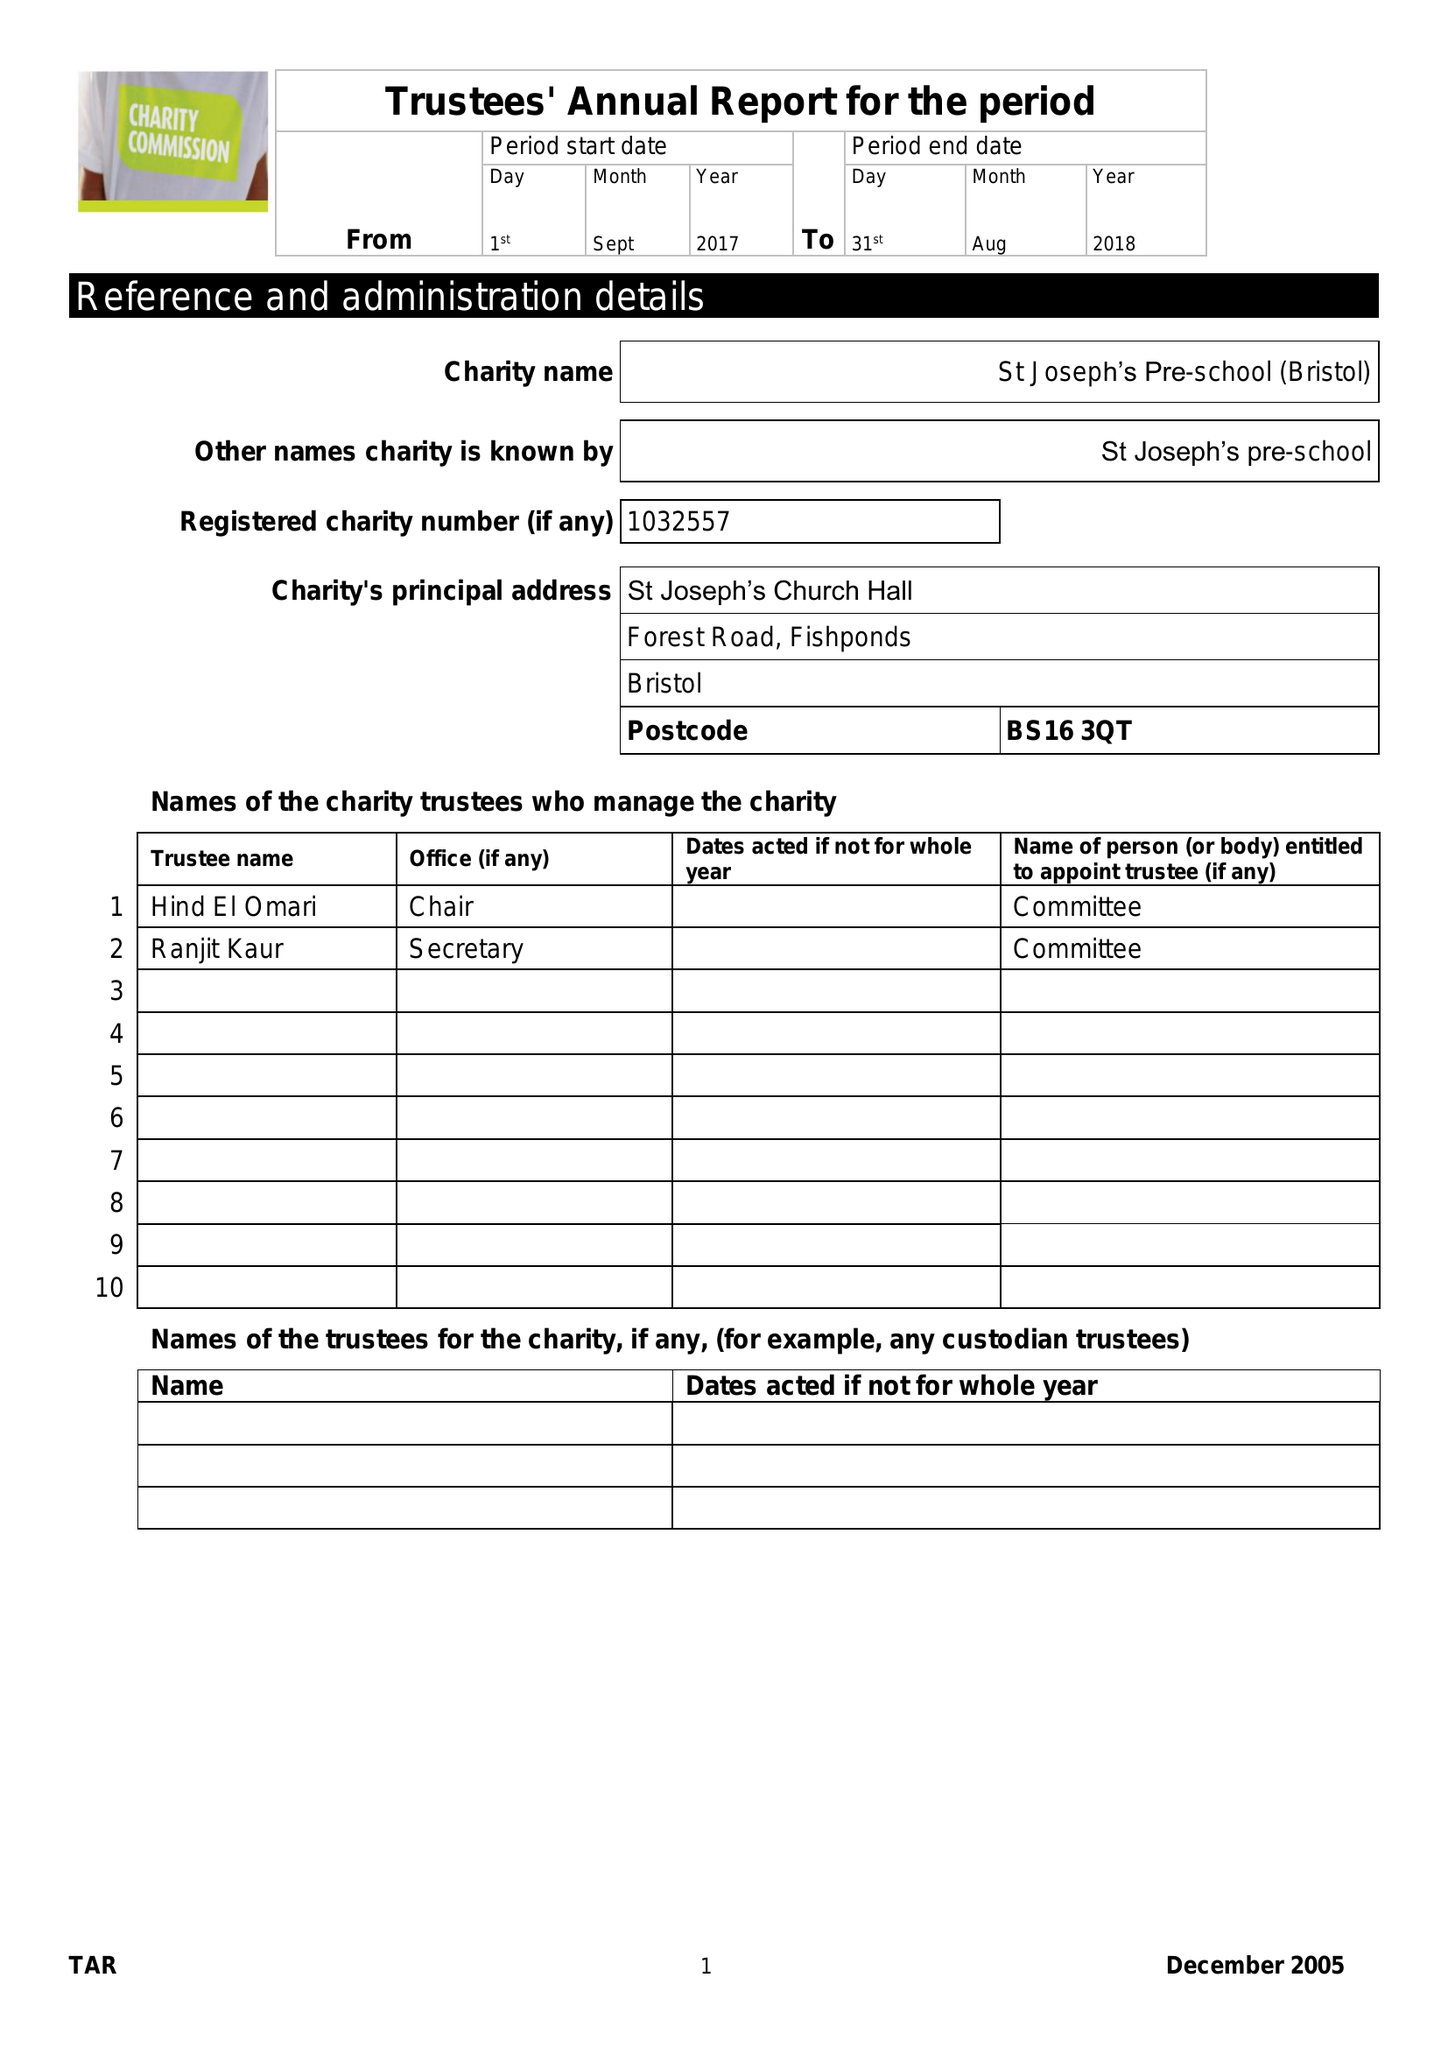What is the value for the address__post_town?
Answer the question using a single word or phrase. BRISTOL 